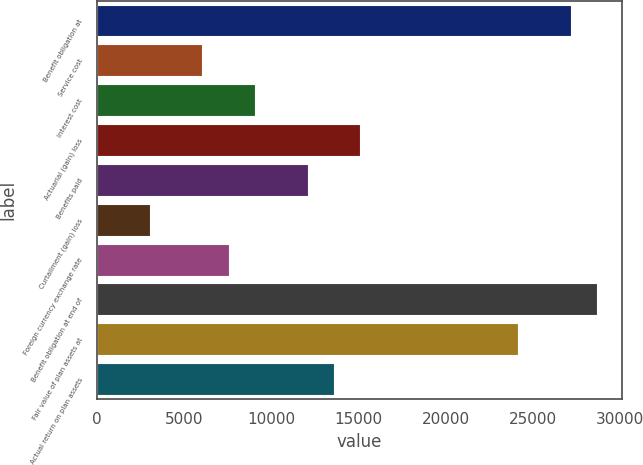Convert chart to OTSL. <chart><loc_0><loc_0><loc_500><loc_500><bar_chart><fcel>Benefit obligation at<fcel>Service cost<fcel>Interest cost<fcel>Actuarial (gain) loss<fcel>Benefits paid<fcel>Curtailment (gain) loss<fcel>Foreign currency exchange rate<fcel>Benefit obligation at end of<fcel>Fair value of plan assets at<fcel>Actual return on plan assets<nl><fcel>27165<fcel>6048.48<fcel>9065.12<fcel>15098.4<fcel>12081.8<fcel>3031.84<fcel>7556.8<fcel>28673.3<fcel>24148.3<fcel>13590.1<nl></chart> 